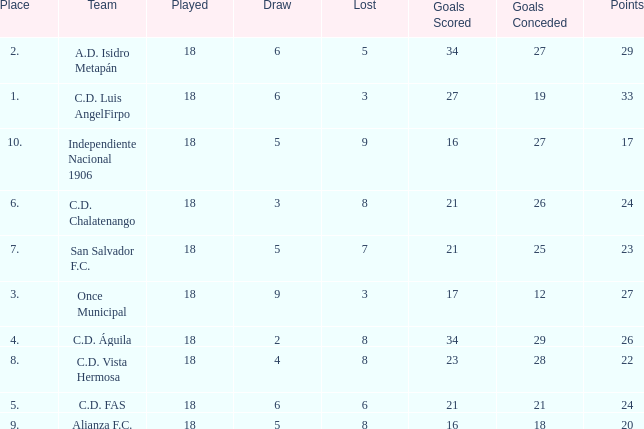How many points were in a game that had a lost of 5, greater than place 2, and 27 goals conceded? 0.0. 